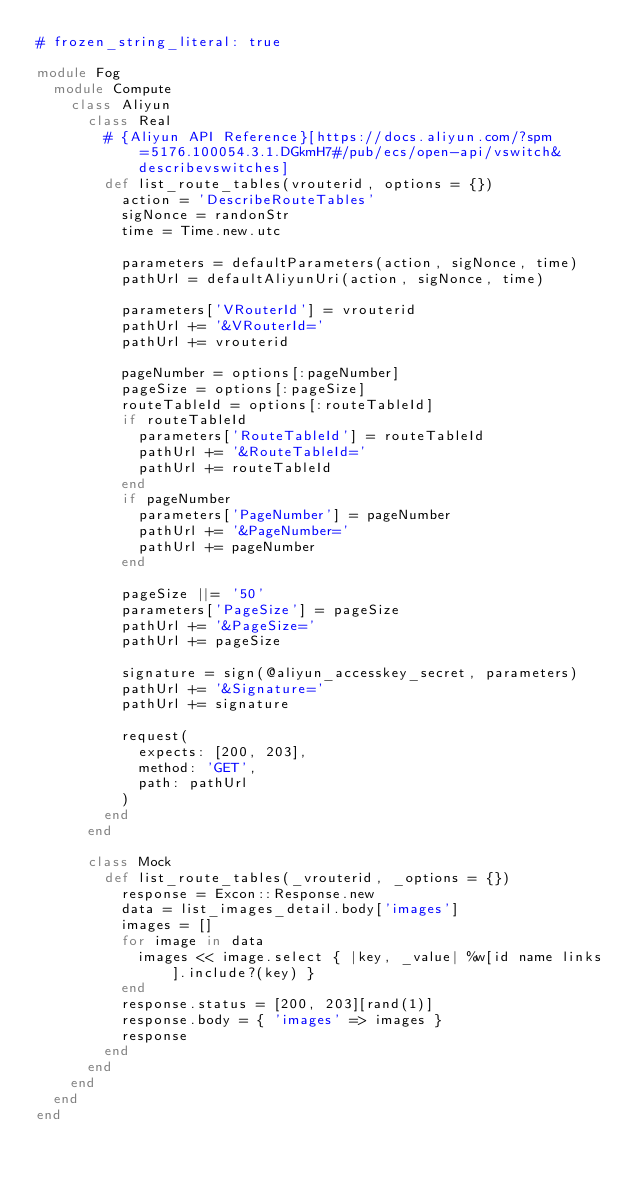<code> <loc_0><loc_0><loc_500><loc_500><_Ruby_># frozen_string_literal: true

module Fog
  module Compute
    class Aliyun
      class Real
        # {Aliyun API Reference}[https://docs.aliyun.com/?spm=5176.100054.3.1.DGkmH7#/pub/ecs/open-api/vswitch&describevswitches]
        def list_route_tables(vrouterid, options = {})
          action = 'DescribeRouteTables'
          sigNonce = randonStr
          time = Time.new.utc

          parameters = defaultParameters(action, sigNonce, time)
          pathUrl = defaultAliyunUri(action, sigNonce, time)

          parameters['VRouterId'] = vrouterid
          pathUrl += '&VRouterId='
          pathUrl += vrouterid

          pageNumber = options[:pageNumber]
          pageSize = options[:pageSize]
          routeTableId = options[:routeTableId]
          if routeTableId
            parameters['RouteTableId'] = routeTableId
            pathUrl += '&RouteTableId='
            pathUrl += routeTableId
          end
          if pageNumber
            parameters['PageNumber'] = pageNumber
            pathUrl += '&PageNumber='
            pathUrl += pageNumber
          end

          pageSize ||= '50'
          parameters['PageSize'] = pageSize
          pathUrl += '&PageSize='
          pathUrl += pageSize

          signature = sign(@aliyun_accesskey_secret, parameters)
          pathUrl += '&Signature='
          pathUrl += signature

          request(
            expects: [200, 203],
            method: 'GET',
            path: pathUrl
          )
        end
      end

      class Mock
        def list_route_tables(_vrouterid, _options = {})
          response = Excon::Response.new
          data = list_images_detail.body['images']
          images = []
          for image in data
            images << image.select { |key, _value| %w[id name links].include?(key) }
          end
          response.status = [200, 203][rand(1)]
          response.body = { 'images' => images }
          response
        end
      end
    end
  end
end
</code> 